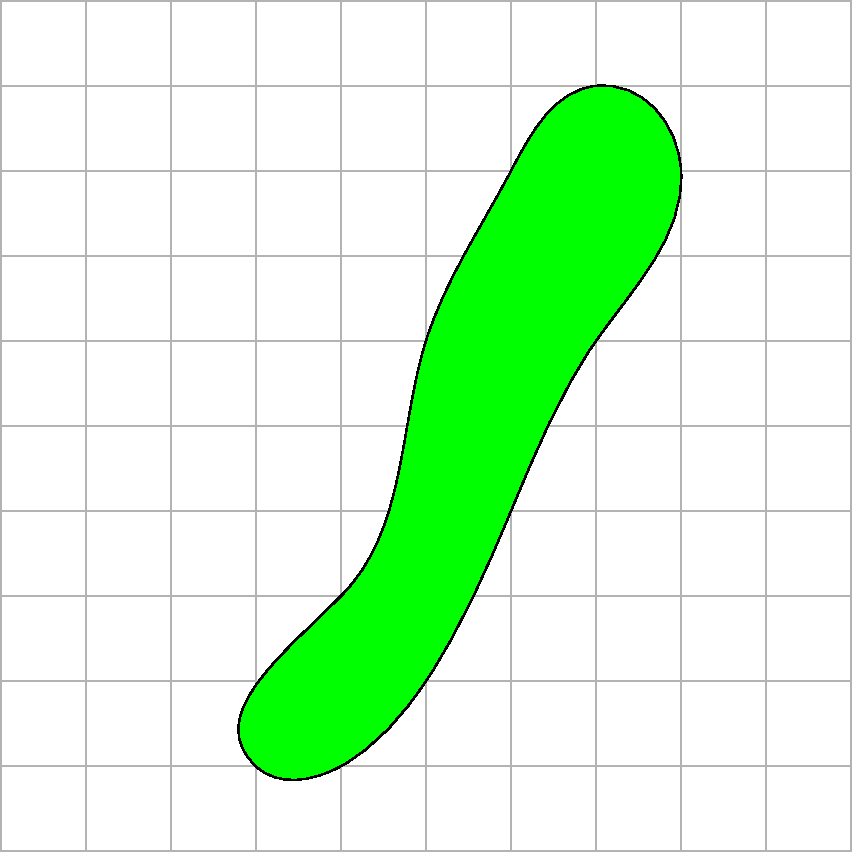En la imagen se muestra la forma de una hoja sobre una cuadrícula donde cada cuadrado representa 1 cm². Estime el área de la hoja contando los cuadrados completos y parciales que ocupa. ¿Cuál es el área aproximada de la hoja en cm²? Para estimar el área de la hoja, seguiremos estos pasos:

1. Contar los cuadrados completos dentro de la hoja:
   Hay aproximadamente 25 cuadrados completos.

2. Contar los cuadrados parciales:
   Hay alrededor de 18 cuadrados parciales en el borde de la hoja.

3. Estimar el área de los cuadrados parciales:
   Asumimos que, en promedio, cada cuadrado parcial representa la mitad de un cuadrado completo.
   Área de cuadrados parciales = $18 \times 0.5 = 9$ cm²

4. Sumar el área de los cuadrados completos y parciales:
   Área total = Área de cuadrados completos + Área de cuadrados parciales
   Área total = $25 + 9 = 34$ cm²

Por lo tanto, el área aproximada de la hoja es de 34 cm².
Answer: 34 cm² 